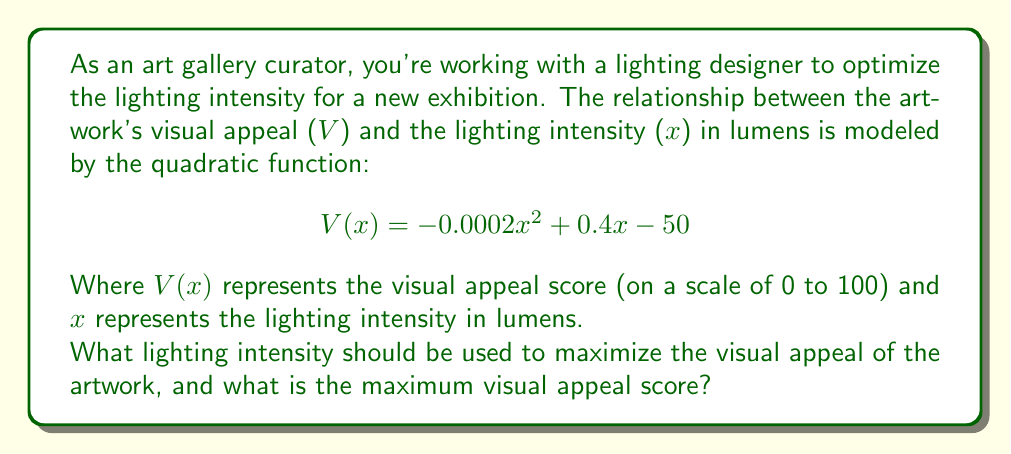Give your solution to this math problem. To solve this problem, we need to find the maximum point of the quadratic function. This can be done by following these steps:

1. The quadratic function is in the form $f(x) = ax^2 + bx + c$, where:
   $a = -0.0002$
   $b = 0.4$
   $c = -50$

2. For a quadratic function, the x-coordinate of the vertex (which gives the maximum or minimum point) is given by the formula:

   $$ x = -\frac{b}{2a} $$

3. Substituting our values:

   $$ x = -\frac{0.4}{2(-0.0002)} = \frac{0.4}{0.0004} = 1000 $$

4. This means the optimal lighting intensity is 1000 lumens.

5. To find the maximum visual appeal score, we substitute x = 1000 into our original function:

   $$ V(1000) = -0.0002(1000)^2 + 0.4(1000) - 50 $$
   $$ = -0.0002(1,000,000) + 400 - 50 $$
   $$ = -200 + 400 - 50 $$
   $$ = 150 $$

6. However, since our scale is from 0 to 100, we need to cap this value at 100.

Therefore, the maximum visual appeal score is 100.
Answer: The optimal lighting intensity is 1000 lumens, and the maximum visual appeal score is 100. 